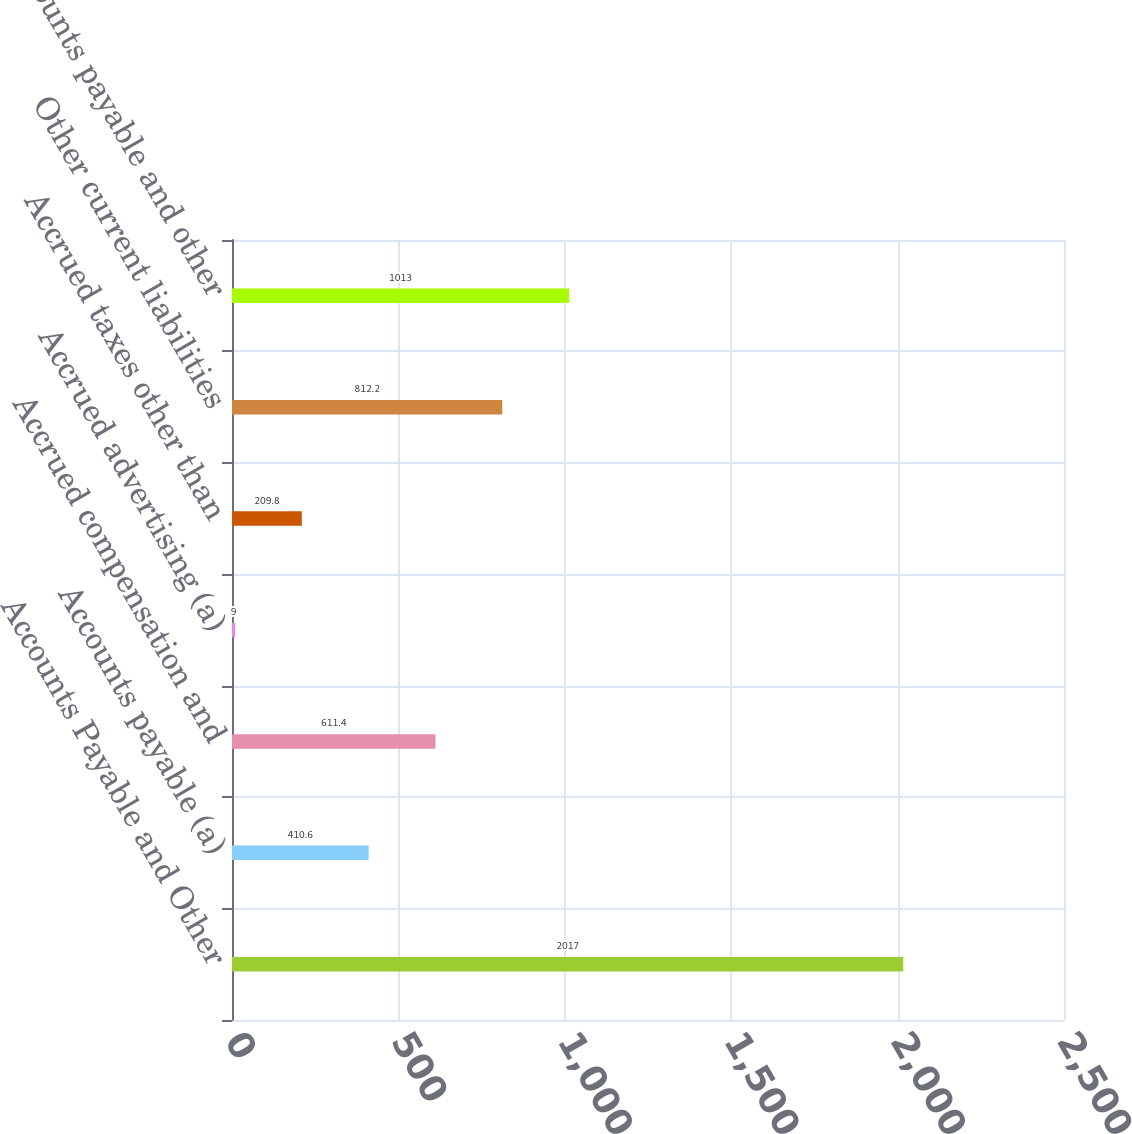Convert chart. <chart><loc_0><loc_0><loc_500><loc_500><bar_chart><fcel>Accounts Payable and Other<fcel>Accounts payable (a)<fcel>Accrued compensation and<fcel>Accrued advertising (a)<fcel>Accrued taxes other than<fcel>Other current liabilities<fcel>Accounts payable and other<nl><fcel>2017<fcel>410.6<fcel>611.4<fcel>9<fcel>209.8<fcel>812.2<fcel>1013<nl></chart> 